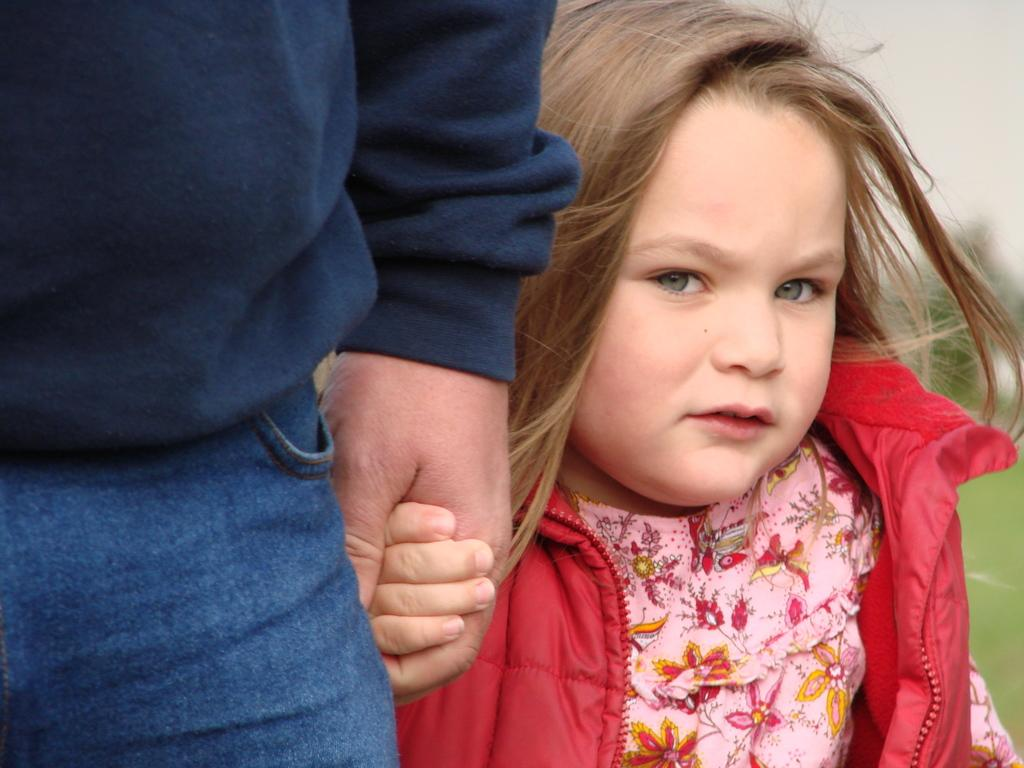How many people are in the image? There are people in the image, but the exact number is not specified. Can you describe the appearance of one of the people? One person is partially covered in the image. What can be said about the background of the image? The background of the image is blurred. What type of bean is being compared to the people in the image? There is no bean present in the image, nor is there any comparison being made between the people and a bean. 